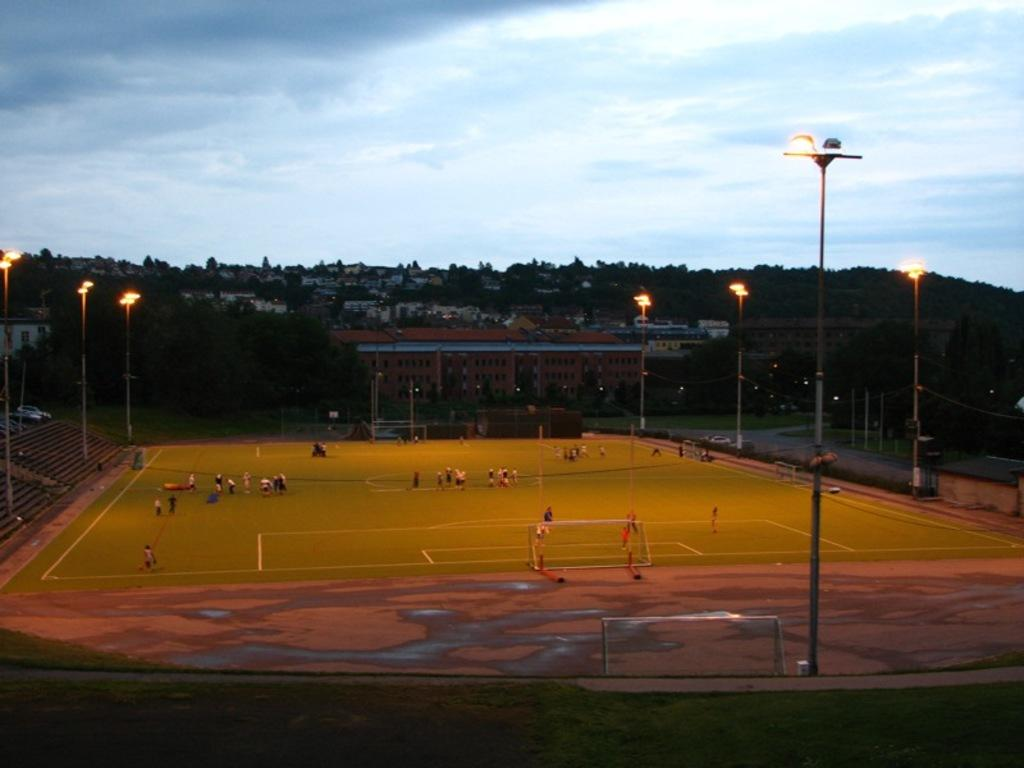What is the main structure visible in the image? There is a stadium in the image. Are there any specific features around the stadium? Yes, there are red lights around the stadium. What can be seen in the background of the image? There are houses and trees in the background of the image. What is the color of the sky in the background of the image? The sky is blue in the background of the image. Can you see any beetles crawling on the stadium in the image? There are no beetles visible in the image; it features a stadium with red lights and a background of houses, trees, and a blue sky. 